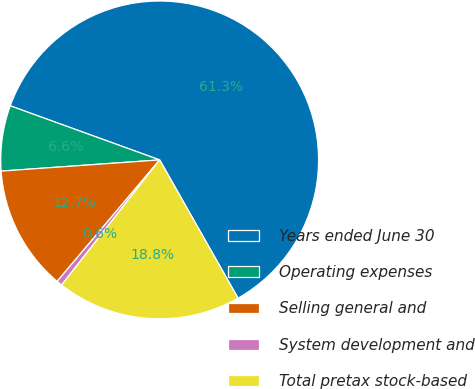Convert chart to OTSL. <chart><loc_0><loc_0><loc_500><loc_500><pie_chart><fcel>Years ended June 30<fcel>Operating expenses<fcel>Selling general and<fcel>System development and<fcel>Total pretax stock-based<nl><fcel>61.27%<fcel>6.65%<fcel>12.72%<fcel>0.58%<fcel>18.79%<nl></chart> 